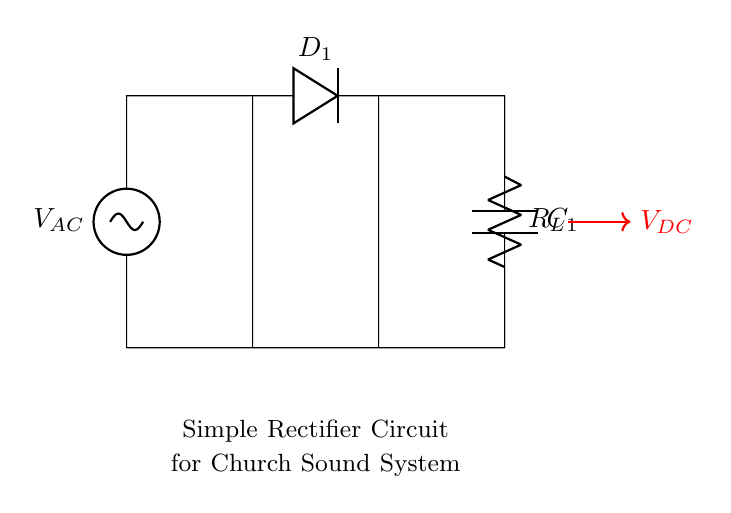What is the input voltage type in this circuit? The circuit shows a voltage source labeled as V_AC, which indicates that it is an alternating current (AC) voltage input.
Answer: AC What type of diode is used in this circuit? The component labeled D_1 in the circuit diagram represents a diode. While the specific type is not indicated, it typically refers to a standard silicon diode used for rectification.
Answer: Diode What is the output voltage type from this circuit? The output voltage is indicated by V_DC in the circuit diagram, which represents a direct current (DC) voltage output after rectification.
Answer: DC Which component smooths the output voltage in this circuit? The capacitor labeled C_1 is the component responsible for smoothing the output voltage, as capacitors help reduce voltage fluctuations in the circuit.
Answer: Capacitor What is the load resistor labeled as in the circuit? The resistor is labeled R_L in the circuit diagram, which indicates it is serving as the load resistor in this rectifier circuit.
Answer: R_L Why is a rectifier needed in a church sound system? A rectifier is needed to convert the alternating current (AC) from the power supply into direct current (DC) to power audio equipment effectively and ensure consistent performance.
Answer: Conversion 